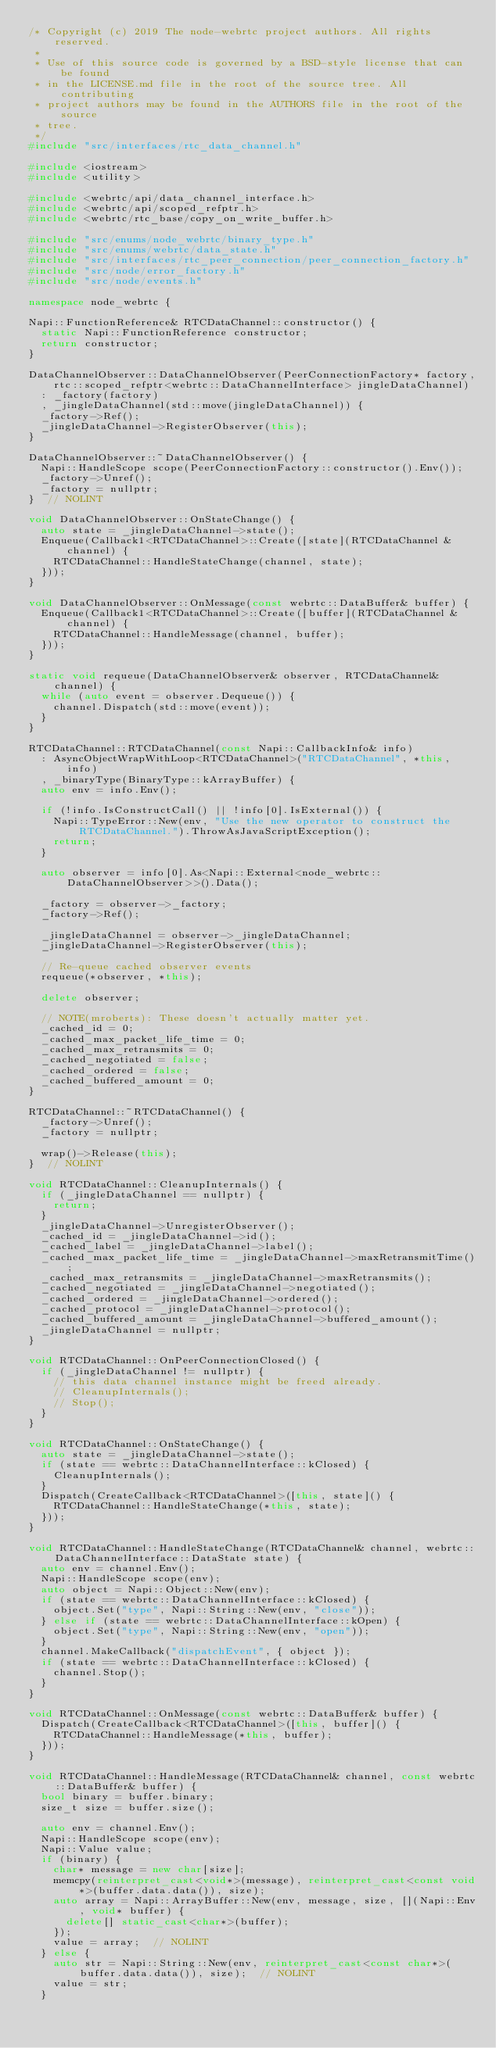Convert code to text. <code><loc_0><loc_0><loc_500><loc_500><_C++_>/* Copyright (c) 2019 The node-webrtc project authors. All rights reserved.
 *
 * Use of this source code is governed by a BSD-style license that can be found
 * in the LICENSE.md file in the root of the source tree. All contributing
 * project authors may be found in the AUTHORS file in the root of the source
 * tree.
 */
#include "src/interfaces/rtc_data_channel.h"

#include <iostream>
#include <utility>

#include <webrtc/api/data_channel_interface.h>
#include <webrtc/api/scoped_refptr.h>
#include <webrtc/rtc_base/copy_on_write_buffer.h>

#include "src/enums/node_webrtc/binary_type.h"
#include "src/enums/webrtc/data_state.h"
#include "src/interfaces/rtc_peer_connection/peer_connection_factory.h"
#include "src/node/error_factory.h"
#include "src/node/events.h"

namespace node_webrtc {

Napi::FunctionReference& RTCDataChannel::constructor() {
  static Napi::FunctionReference constructor;
  return constructor;
}

DataChannelObserver::DataChannelObserver(PeerConnectionFactory* factory,
    rtc::scoped_refptr<webrtc::DataChannelInterface> jingleDataChannel)
  : _factory(factory)
  , _jingleDataChannel(std::move(jingleDataChannel)) {
  _factory->Ref();
  _jingleDataChannel->RegisterObserver(this);
}

DataChannelObserver::~DataChannelObserver() {
  Napi::HandleScope scope(PeerConnectionFactory::constructor().Env());
  _factory->Unref();
  _factory = nullptr;
}  // NOLINT

void DataChannelObserver::OnStateChange() {
  auto state = _jingleDataChannel->state();
  Enqueue(Callback1<RTCDataChannel>::Create([state](RTCDataChannel & channel) {
    RTCDataChannel::HandleStateChange(channel, state);
  }));
}

void DataChannelObserver::OnMessage(const webrtc::DataBuffer& buffer) {
  Enqueue(Callback1<RTCDataChannel>::Create([buffer](RTCDataChannel & channel) {
    RTCDataChannel::HandleMessage(channel, buffer);
  }));
}

static void requeue(DataChannelObserver& observer, RTCDataChannel& channel) {
  while (auto event = observer.Dequeue()) {
    channel.Dispatch(std::move(event));
  }
}

RTCDataChannel::RTCDataChannel(const Napi::CallbackInfo& info)
  : AsyncObjectWrapWithLoop<RTCDataChannel>("RTCDataChannel", *this, info)
  , _binaryType(BinaryType::kArrayBuffer) {
  auto env = info.Env();

  if (!info.IsConstructCall() || !info[0].IsExternal()) {
    Napi::TypeError::New(env, "Use the new operator to construct the RTCDataChannel.").ThrowAsJavaScriptException();
    return;
  }

  auto observer = info[0].As<Napi::External<node_webrtc::DataChannelObserver>>().Data();

  _factory = observer->_factory;
  _factory->Ref();

  _jingleDataChannel = observer->_jingleDataChannel;
  _jingleDataChannel->RegisterObserver(this);

  // Re-queue cached observer events
  requeue(*observer, *this);

  delete observer;

  // NOTE(mroberts): These doesn't actually matter yet.
  _cached_id = 0;
  _cached_max_packet_life_time = 0;
  _cached_max_retransmits = 0;
  _cached_negotiated = false;
  _cached_ordered = false;
  _cached_buffered_amount = 0;
}

RTCDataChannel::~RTCDataChannel() {
  _factory->Unref();
  _factory = nullptr;

  wrap()->Release(this);
}  // NOLINT

void RTCDataChannel::CleanupInternals() {
  if (_jingleDataChannel == nullptr) {
    return;
  }
  _jingleDataChannel->UnregisterObserver();
  _cached_id = _jingleDataChannel->id();
  _cached_label = _jingleDataChannel->label();
  _cached_max_packet_life_time = _jingleDataChannel->maxRetransmitTime();
  _cached_max_retransmits = _jingleDataChannel->maxRetransmits();
  _cached_negotiated = _jingleDataChannel->negotiated();
  _cached_ordered = _jingleDataChannel->ordered();
  _cached_protocol = _jingleDataChannel->protocol();
  _cached_buffered_amount = _jingleDataChannel->buffered_amount();
  _jingleDataChannel = nullptr;
}

void RTCDataChannel::OnPeerConnectionClosed() {
  if (_jingleDataChannel != nullptr) {
    // this data channel instance might be freed already.
    // CleanupInternals();
    // Stop();
  }
}

void RTCDataChannel::OnStateChange() {
  auto state = _jingleDataChannel->state();
  if (state == webrtc::DataChannelInterface::kClosed) {
    CleanupInternals();
  }
  Dispatch(CreateCallback<RTCDataChannel>([this, state]() {
    RTCDataChannel::HandleStateChange(*this, state);
  }));
}

void RTCDataChannel::HandleStateChange(RTCDataChannel& channel, webrtc::DataChannelInterface::DataState state) {
  auto env = channel.Env();
  Napi::HandleScope scope(env);
  auto object = Napi::Object::New(env);
  if (state == webrtc::DataChannelInterface::kClosed) {
    object.Set("type", Napi::String::New(env, "close"));
  } else if (state == webrtc::DataChannelInterface::kOpen) {
    object.Set("type", Napi::String::New(env, "open"));
  }
  channel.MakeCallback("dispatchEvent", { object });
  if (state == webrtc::DataChannelInterface::kClosed) {
    channel.Stop();
  }
}

void RTCDataChannel::OnMessage(const webrtc::DataBuffer& buffer) {
  Dispatch(CreateCallback<RTCDataChannel>([this, buffer]() {
    RTCDataChannel::HandleMessage(*this, buffer);
  }));
}

void RTCDataChannel::HandleMessage(RTCDataChannel& channel, const webrtc::DataBuffer& buffer) {
  bool binary = buffer.binary;
  size_t size = buffer.size();

  auto env = channel.Env();
  Napi::HandleScope scope(env);
  Napi::Value value;
  if (binary) {
    char* message = new char[size];
    memcpy(reinterpret_cast<void*>(message), reinterpret_cast<const void*>(buffer.data.data()), size);
    auto array = Napi::ArrayBuffer::New(env, message, size, [](Napi::Env, void* buffer) {
      delete[] static_cast<char*>(buffer);
    });
    value = array;  // NOLINT
  } else {
    auto str = Napi::String::New(env, reinterpret_cast<const char*>(buffer.data.data()), size);  // NOLINT
    value = str;
  }</code> 